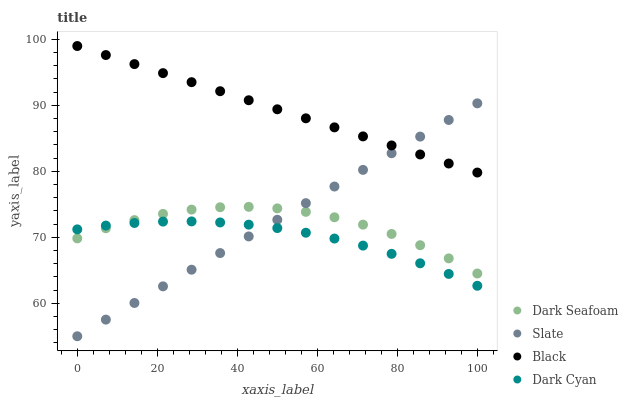Does Dark Cyan have the minimum area under the curve?
Answer yes or no. Yes. Does Black have the maximum area under the curve?
Answer yes or no. Yes. Does Dark Seafoam have the minimum area under the curve?
Answer yes or no. No. Does Dark Seafoam have the maximum area under the curve?
Answer yes or no. No. Is Black the smoothest?
Answer yes or no. Yes. Is Dark Seafoam the roughest?
Answer yes or no. Yes. Is Dark Seafoam the smoothest?
Answer yes or no. No. Is Black the roughest?
Answer yes or no. No. Does Slate have the lowest value?
Answer yes or no. Yes. Does Dark Seafoam have the lowest value?
Answer yes or no. No. Does Black have the highest value?
Answer yes or no. Yes. Does Dark Seafoam have the highest value?
Answer yes or no. No. Is Dark Cyan less than Black?
Answer yes or no. Yes. Is Black greater than Dark Seafoam?
Answer yes or no. Yes. Does Slate intersect Dark Cyan?
Answer yes or no. Yes. Is Slate less than Dark Cyan?
Answer yes or no. No. Is Slate greater than Dark Cyan?
Answer yes or no. No. Does Dark Cyan intersect Black?
Answer yes or no. No. 